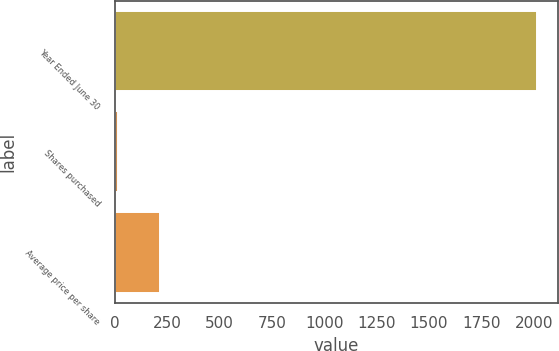Convert chart. <chart><loc_0><loc_0><loc_500><loc_500><bar_chart><fcel>Year Ended June 30<fcel>Shares purchased<fcel>Average price per share<nl><fcel>2016<fcel>15<fcel>215.1<nl></chart> 